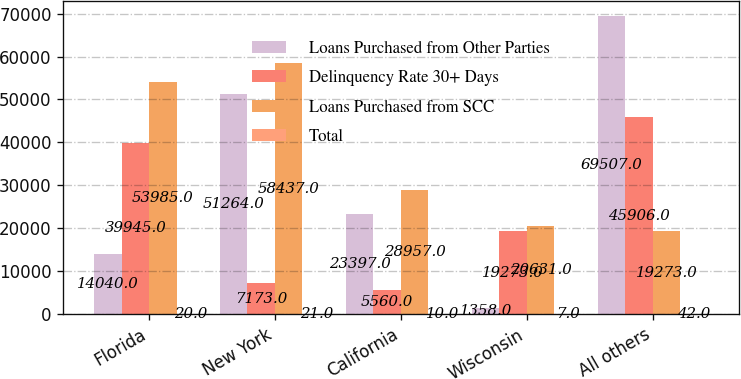<chart> <loc_0><loc_0><loc_500><loc_500><stacked_bar_chart><ecel><fcel>Florida<fcel>New York<fcel>California<fcel>Wisconsin<fcel>All others<nl><fcel>Loans Purchased from Other Parties<fcel>14040<fcel>51264<fcel>23397<fcel>1358<fcel>69507<nl><fcel>Delinquency Rate 30+ Days<fcel>39945<fcel>7173<fcel>5560<fcel>19273<fcel>45906<nl><fcel>Loans Purchased from SCC<fcel>53985<fcel>58437<fcel>28957<fcel>20631<fcel>19273<nl><fcel>Total<fcel>20<fcel>21<fcel>10<fcel>7<fcel>42<nl></chart> 